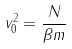Convert formula to latex. <formula><loc_0><loc_0><loc_500><loc_500>v _ { 0 } ^ { 2 } = \frac { N } { \beta m }</formula> 